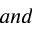<formula> <loc_0><loc_0><loc_500><loc_500>a n d</formula> 